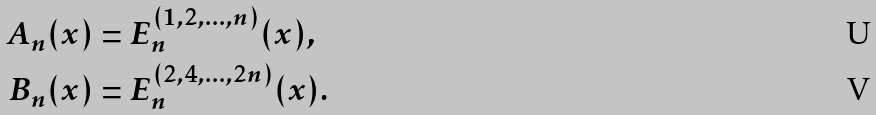<formula> <loc_0><loc_0><loc_500><loc_500>A _ { n } ( x ) & = E _ { n } ^ { ( 1 , 2 , \dots , n ) } ( x ) , \\ B _ { n } ( x ) & = E _ { n } ^ { ( 2 , 4 , \dots , 2 n ) } ( x ) .</formula> 